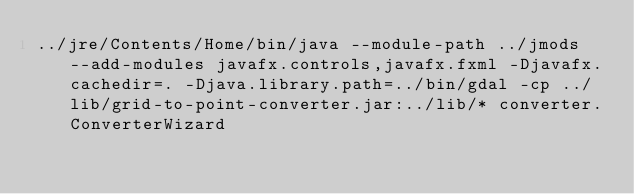<code> <loc_0><loc_0><loc_500><loc_500><_Bash_>../jre/Contents/Home/bin/java --module-path ../jmods --add-modules javafx.controls,javafx.fxml -Djavafx.cachedir=. -Djava.library.path=../bin/gdal -cp ../lib/grid-to-point-converter.jar:../lib/* converter.ConverterWizard
</code> 